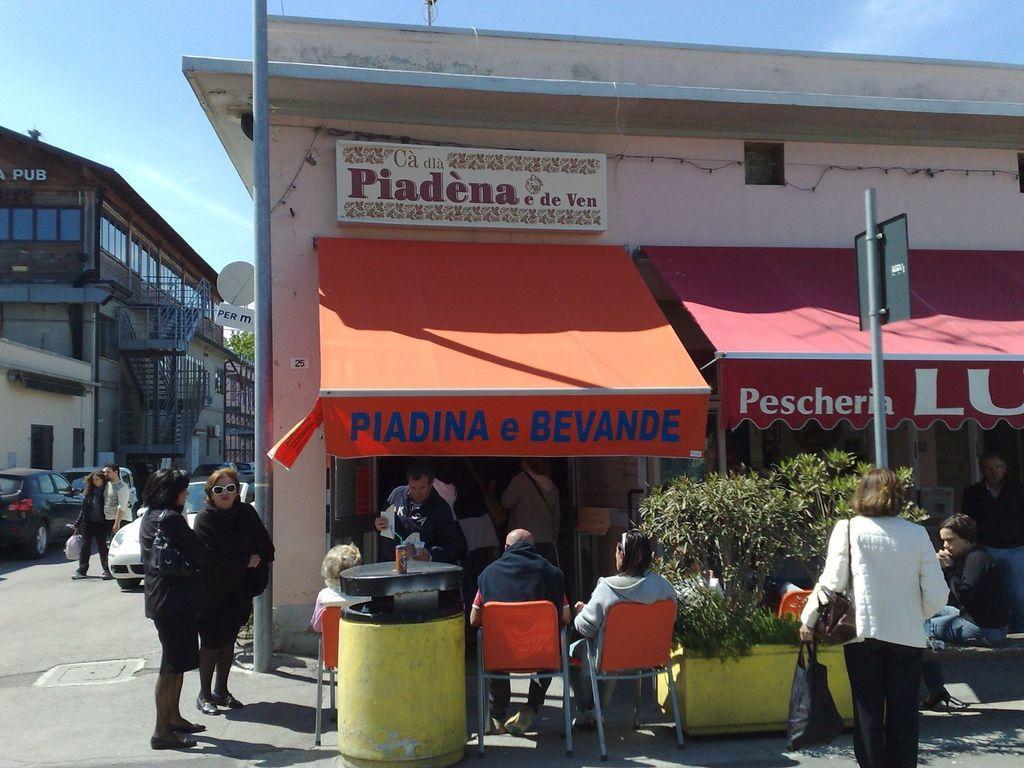How would you summarize this image in a sentence or two? This picture shows people sitting in front of a shop in the chairs. Some of them were standing here. There are some plants. In the background there is a car on the road and some buildings here. We can observe a sky too. 